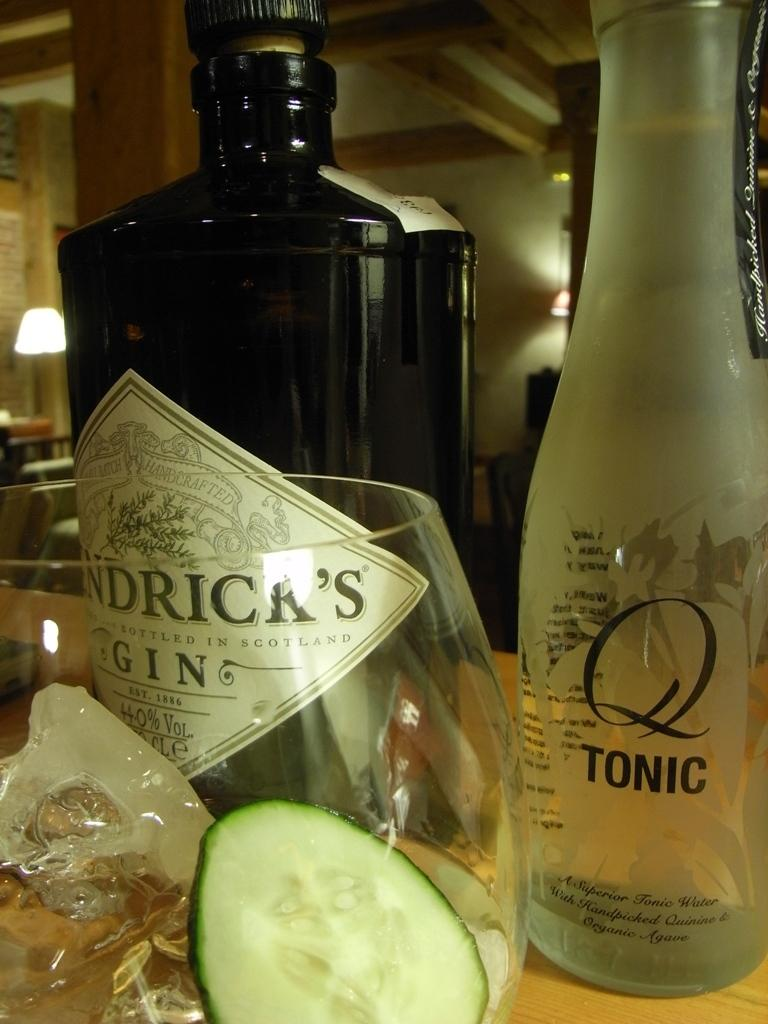How many bottles can be seen in the image? There are two bottles in the image. What is inside the glass in the image? There is a glass with radish pieces in the image. What can be seen in the background of the image? There is a pillar, a light, and a wall in the background of the image. What type of button is the parent using to control the light in the image? There is no parent or button present in the image. The light in the background is not controlled by a button in the image. 